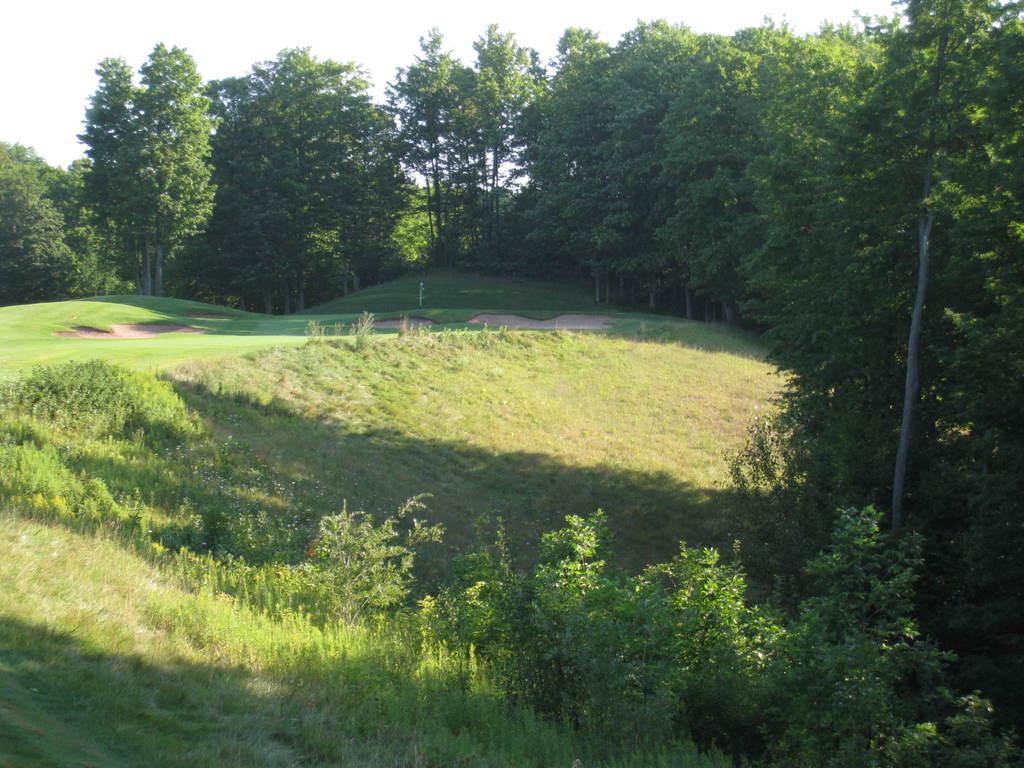Describe this image in one or two sentences. This picture is clicked outside. In the foreground we can see the plants and the green grass. In the background we can see the sky and the trees. 